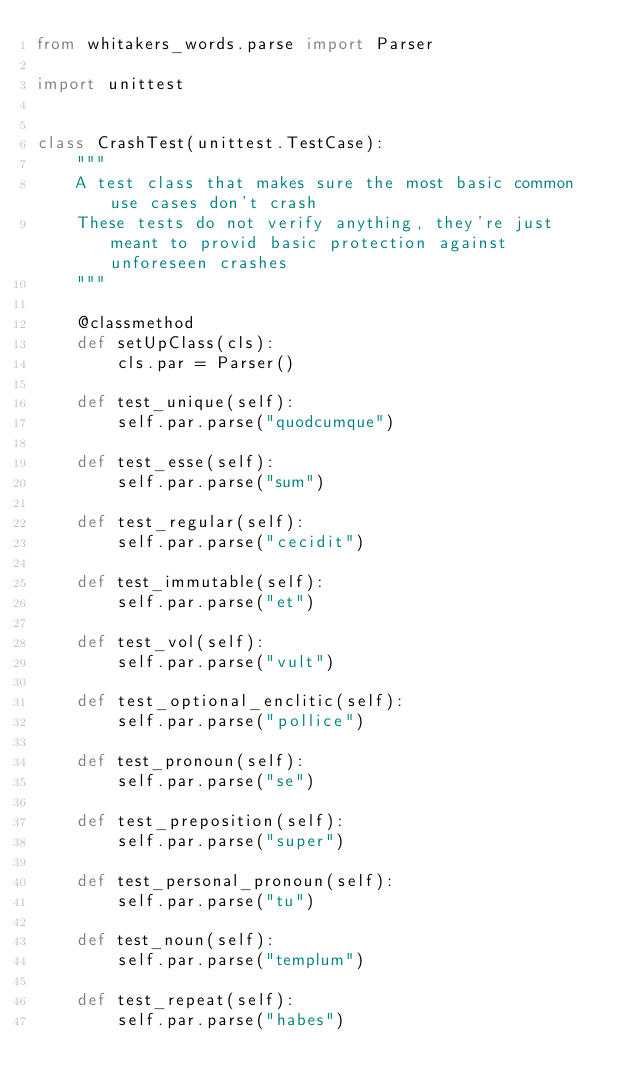Convert code to text. <code><loc_0><loc_0><loc_500><loc_500><_Python_>from whitakers_words.parse import Parser

import unittest


class CrashTest(unittest.TestCase):
    """
    A test class that makes sure the most basic common use cases don't crash
    These tests do not verify anything, they're just meant to provid basic protection against unforeseen crashes
    """

    @classmethod
    def setUpClass(cls):
        cls.par = Parser()

    def test_unique(self):
        self.par.parse("quodcumque")

    def test_esse(self):
        self.par.parse("sum")

    def test_regular(self):
        self.par.parse("cecidit")

    def test_immutable(self):
        self.par.parse("et")

    def test_vol(self):
        self.par.parse("vult")

    def test_optional_enclitic(self):
        self.par.parse("pollice")

    def test_pronoun(self):
        self.par.parse("se")

    def test_preposition(self):
        self.par.parse("super")

    def test_personal_pronoun(self):
        self.par.parse("tu")

    def test_noun(self):
        self.par.parse("templum")

    def test_repeat(self):
        self.par.parse("habes")</code> 